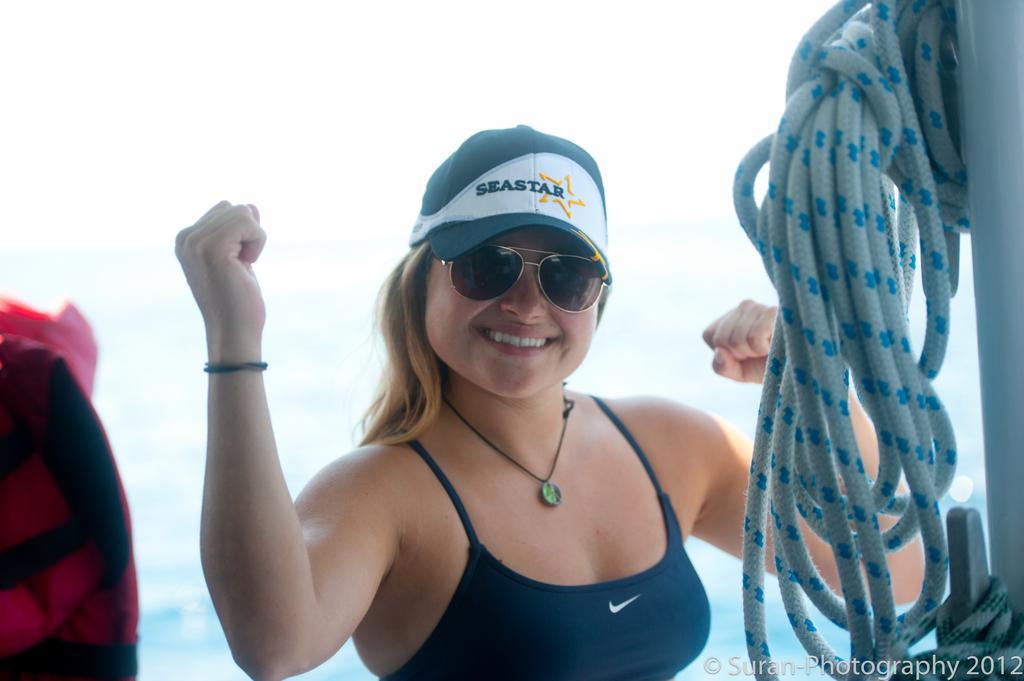Can you describe this image briefly? In this image we can see a woman standing and smiling. In addition to this we can see sky, water and a rope hanged to a pole. 